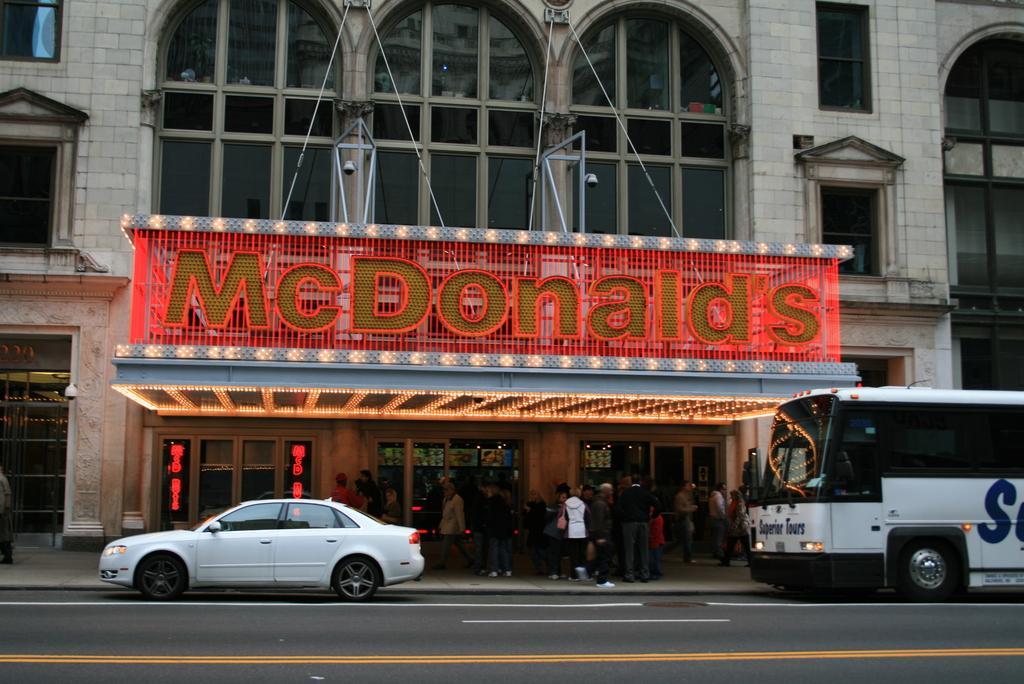In one or two sentences, can you explain what this image depicts? This is a building with the windows and glass doors. There are groups of people standing. I can see a car and a bus on the road. This is a name board, which is attached to the building. 